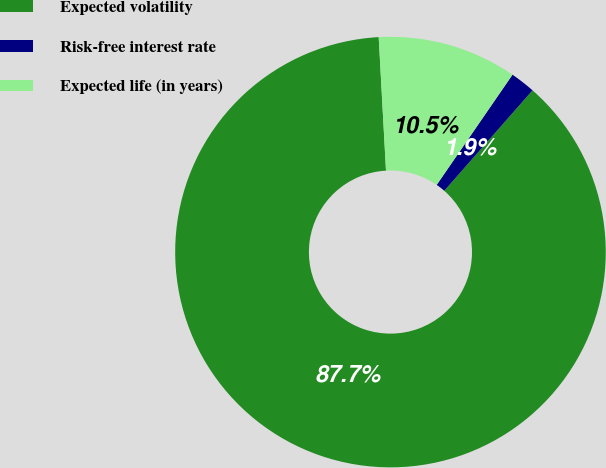Convert chart. <chart><loc_0><loc_0><loc_500><loc_500><pie_chart><fcel>Expected volatility<fcel>Risk-free interest rate<fcel>Expected life (in years)<nl><fcel>87.65%<fcel>1.88%<fcel>10.46%<nl></chart> 